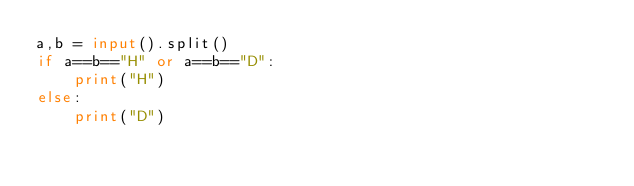<code> <loc_0><loc_0><loc_500><loc_500><_Python_>a,b = input().split()
if a==b=="H" or a==b=="D":
    print("H")
else:
    print("D")</code> 